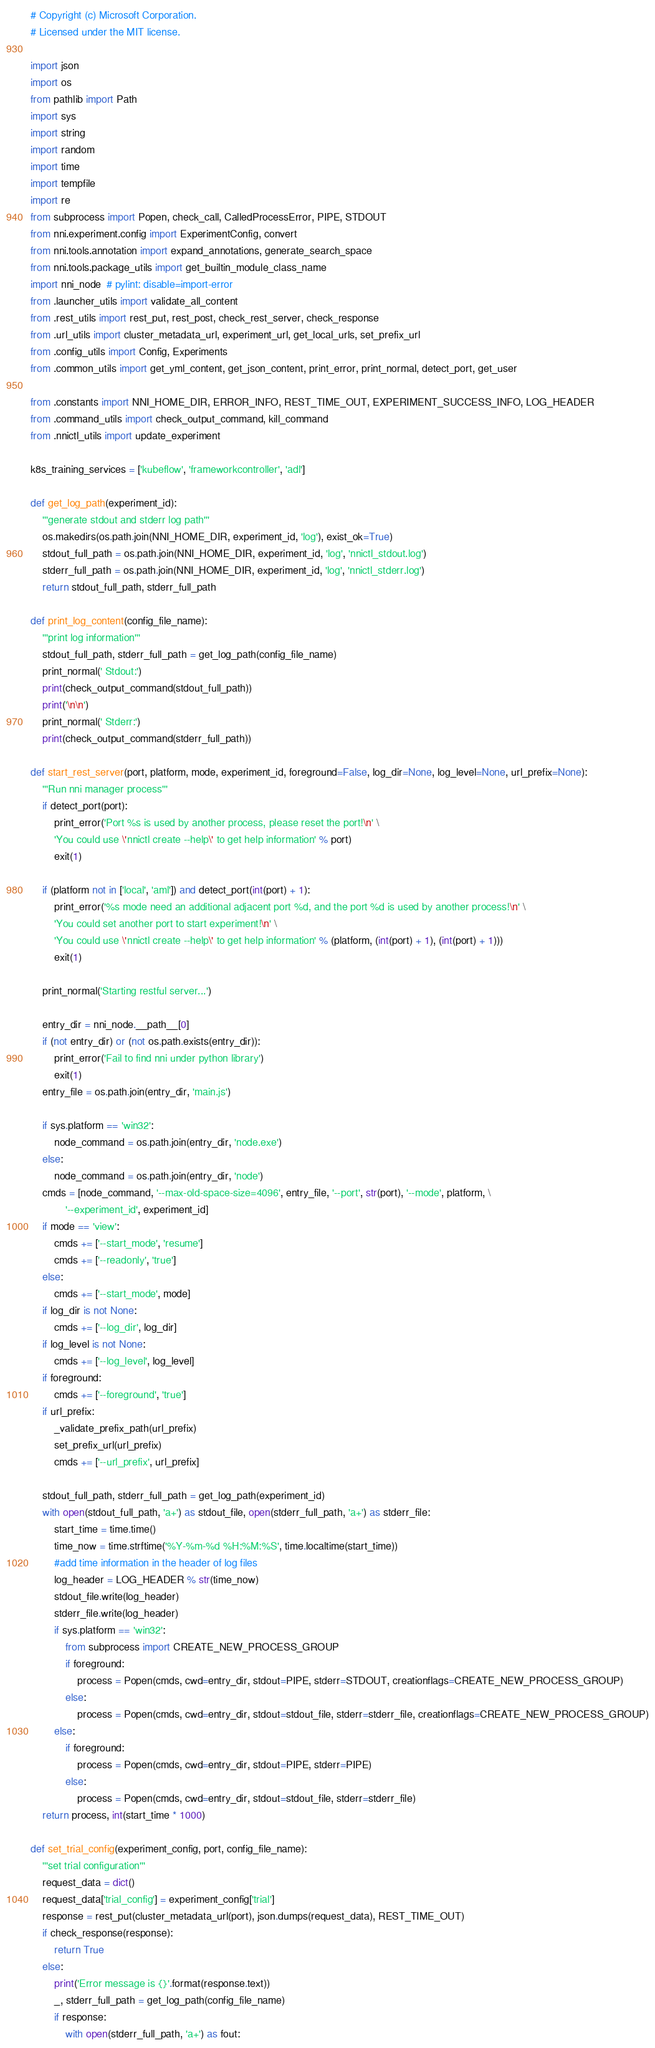Convert code to text. <code><loc_0><loc_0><loc_500><loc_500><_Python_># Copyright (c) Microsoft Corporation.
# Licensed under the MIT license.

import json
import os
from pathlib import Path
import sys
import string
import random
import time
import tempfile
import re
from subprocess import Popen, check_call, CalledProcessError, PIPE, STDOUT
from nni.experiment.config import ExperimentConfig, convert
from nni.tools.annotation import expand_annotations, generate_search_space
from nni.tools.package_utils import get_builtin_module_class_name
import nni_node  # pylint: disable=import-error
from .launcher_utils import validate_all_content
from .rest_utils import rest_put, rest_post, check_rest_server, check_response
from .url_utils import cluster_metadata_url, experiment_url, get_local_urls, set_prefix_url
from .config_utils import Config, Experiments
from .common_utils import get_yml_content, get_json_content, print_error, print_normal, detect_port, get_user

from .constants import NNI_HOME_DIR, ERROR_INFO, REST_TIME_OUT, EXPERIMENT_SUCCESS_INFO, LOG_HEADER
from .command_utils import check_output_command, kill_command
from .nnictl_utils import update_experiment

k8s_training_services = ['kubeflow', 'frameworkcontroller', 'adl']

def get_log_path(experiment_id):
    '''generate stdout and stderr log path'''
    os.makedirs(os.path.join(NNI_HOME_DIR, experiment_id, 'log'), exist_ok=True)
    stdout_full_path = os.path.join(NNI_HOME_DIR, experiment_id, 'log', 'nnictl_stdout.log')
    stderr_full_path = os.path.join(NNI_HOME_DIR, experiment_id, 'log', 'nnictl_stderr.log')
    return stdout_full_path, stderr_full_path

def print_log_content(config_file_name):
    '''print log information'''
    stdout_full_path, stderr_full_path = get_log_path(config_file_name)
    print_normal(' Stdout:')
    print(check_output_command(stdout_full_path))
    print('\n\n')
    print_normal(' Stderr:')
    print(check_output_command(stderr_full_path))

def start_rest_server(port, platform, mode, experiment_id, foreground=False, log_dir=None, log_level=None, url_prefix=None):
    '''Run nni manager process'''
    if detect_port(port):
        print_error('Port %s is used by another process, please reset the port!\n' \
        'You could use \'nnictl create --help\' to get help information' % port)
        exit(1)

    if (platform not in ['local', 'aml']) and detect_port(int(port) + 1):
        print_error('%s mode need an additional adjacent port %d, and the port %d is used by another process!\n' \
        'You could set another port to start experiment!\n' \
        'You could use \'nnictl create --help\' to get help information' % (platform, (int(port) + 1), (int(port) + 1)))
        exit(1)

    print_normal('Starting restful server...')

    entry_dir = nni_node.__path__[0]
    if (not entry_dir) or (not os.path.exists(entry_dir)):
        print_error('Fail to find nni under python library')
        exit(1)
    entry_file = os.path.join(entry_dir, 'main.js')

    if sys.platform == 'win32':
        node_command = os.path.join(entry_dir, 'node.exe')
    else:
        node_command = os.path.join(entry_dir, 'node')
    cmds = [node_command, '--max-old-space-size=4096', entry_file, '--port', str(port), '--mode', platform, \
            '--experiment_id', experiment_id]
    if mode == 'view':
        cmds += ['--start_mode', 'resume']
        cmds += ['--readonly', 'true']
    else:
        cmds += ['--start_mode', mode]
    if log_dir is not None:
        cmds += ['--log_dir', log_dir]
    if log_level is not None:
        cmds += ['--log_level', log_level]
    if foreground:
        cmds += ['--foreground', 'true']
    if url_prefix:
        _validate_prefix_path(url_prefix)
        set_prefix_url(url_prefix)
        cmds += ['--url_prefix', url_prefix]

    stdout_full_path, stderr_full_path = get_log_path(experiment_id)
    with open(stdout_full_path, 'a+') as stdout_file, open(stderr_full_path, 'a+') as stderr_file:
        start_time = time.time()
        time_now = time.strftime('%Y-%m-%d %H:%M:%S', time.localtime(start_time))
        #add time information in the header of log files
        log_header = LOG_HEADER % str(time_now)
        stdout_file.write(log_header)
        stderr_file.write(log_header)
        if sys.platform == 'win32':
            from subprocess import CREATE_NEW_PROCESS_GROUP
            if foreground:
                process = Popen(cmds, cwd=entry_dir, stdout=PIPE, stderr=STDOUT, creationflags=CREATE_NEW_PROCESS_GROUP)
            else:
                process = Popen(cmds, cwd=entry_dir, stdout=stdout_file, stderr=stderr_file, creationflags=CREATE_NEW_PROCESS_GROUP)
        else:
            if foreground:
                process = Popen(cmds, cwd=entry_dir, stdout=PIPE, stderr=PIPE)
            else:
                process = Popen(cmds, cwd=entry_dir, stdout=stdout_file, stderr=stderr_file)
    return process, int(start_time * 1000)

def set_trial_config(experiment_config, port, config_file_name):
    '''set trial configuration'''
    request_data = dict()
    request_data['trial_config'] = experiment_config['trial']
    response = rest_put(cluster_metadata_url(port), json.dumps(request_data), REST_TIME_OUT)
    if check_response(response):
        return True
    else:
        print('Error message is {}'.format(response.text))
        _, stderr_full_path = get_log_path(config_file_name)
        if response:
            with open(stderr_full_path, 'a+') as fout:</code> 